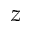Convert formula to latex. <formula><loc_0><loc_0><loc_500><loc_500>z</formula> 